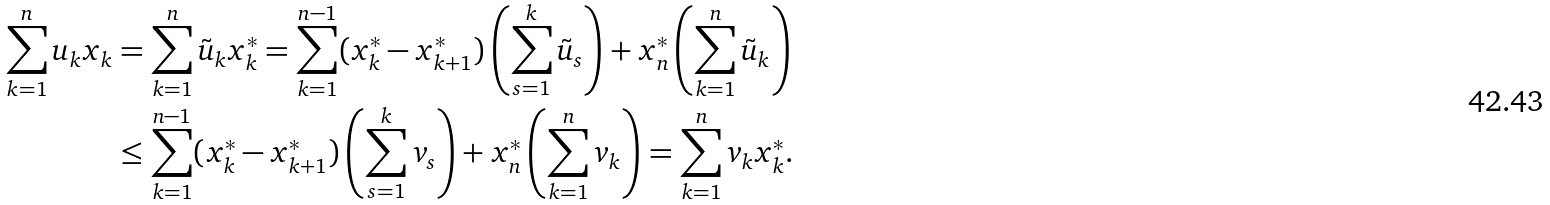Convert formula to latex. <formula><loc_0><loc_0><loc_500><loc_500>\sum _ { k = 1 } ^ { n } u _ { k } x _ { k } & = \sum _ { k = 1 } ^ { n } \tilde { u } _ { k } x _ { k } ^ { * } = \sum _ { k = 1 } ^ { n - 1 } ( x _ { k } ^ { * } - x _ { k + 1 } ^ { * } ) \left ( \sum _ { s = 1 } ^ { k } \tilde { u } _ { s } \right ) + x _ { n } ^ { * } \left ( \sum _ { k = 1 } ^ { n } \tilde { u } _ { k } \right ) \\ & \leq \sum _ { k = 1 } ^ { n - 1 } ( x _ { k } ^ { * } - x _ { k + 1 } ^ { * } ) \left ( \sum _ { s = 1 } ^ { k } v _ { s } \right ) + x _ { n } ^ { * } \left ( \sum _ { k = 1 } ^ { n } v _ { k } \right ) = \sum _ { k = 1 } ^ { n } v _ { k } x _ { k } ^ { * } .</formula> 